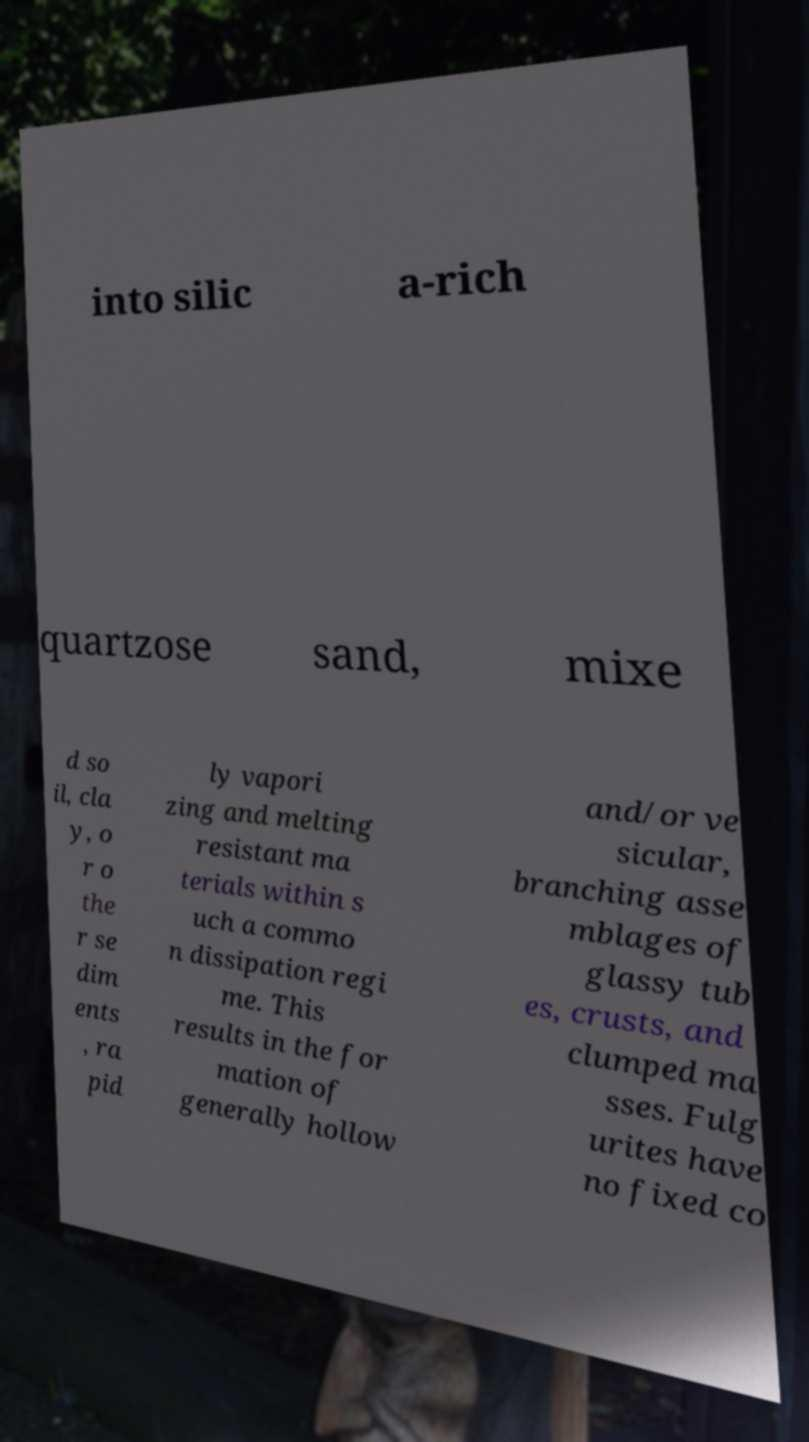Please read and relay the text visible in this image. What does it say? into silic a-rich quartzose sand, mixe d so il, cla y, o r o the r se dim ents , ra pid ly vapori zing and melting resistant ma terials within s uch a commo n dissipation regi me. This results in the for mation of generally hollow and/or ve sicular, branching asse mblages of glassy tub es, crusts, and clumped ma sses. Fulg urites have no fixed co 